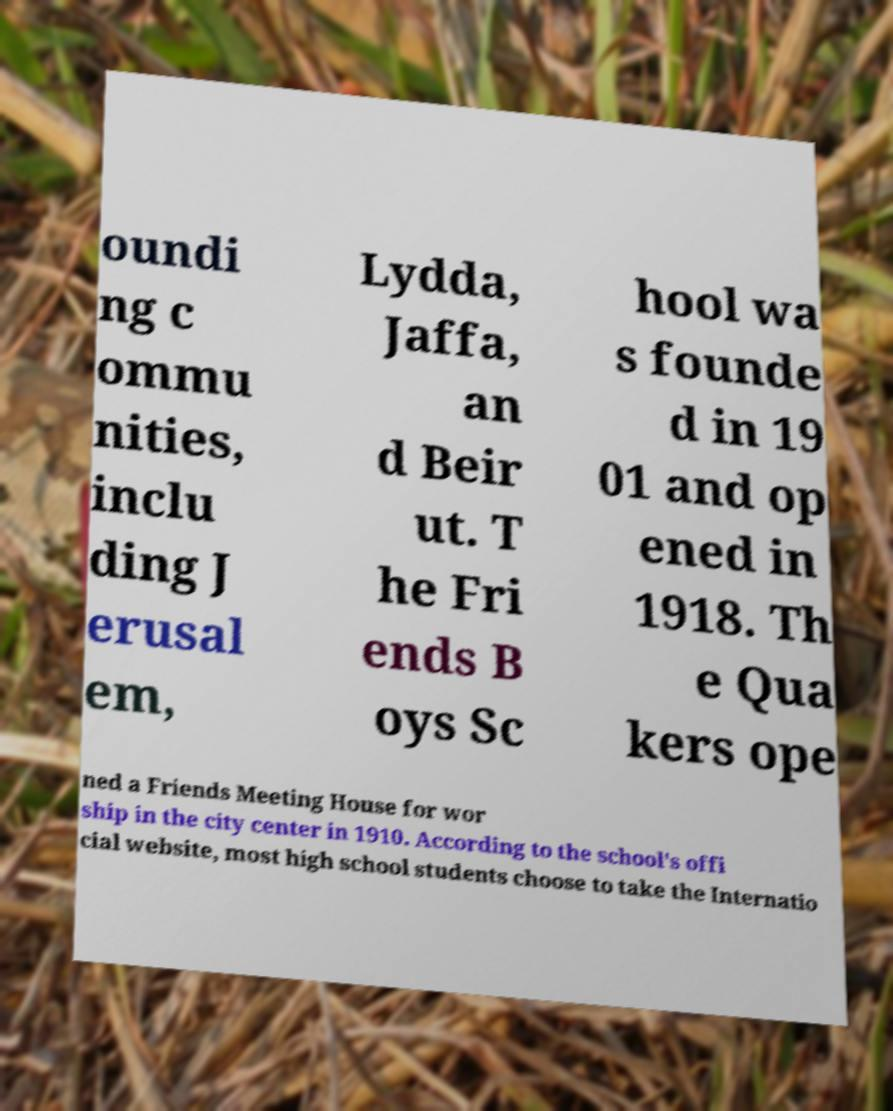Please identify and transcribe the text found in this image. oundi ng c ommu nities, inclu ding J erusal em, Lydda, Jaffa, an d Beir ut. T he Fri ends B oys Sc hool wa s founde d in 19 01 and op ened in 1918. Th e Qua kers ope ned a Friends Meeting House for wor ship in the city center in 1910. According to the school's offi cial website, most high school students choose to take the Internatio 